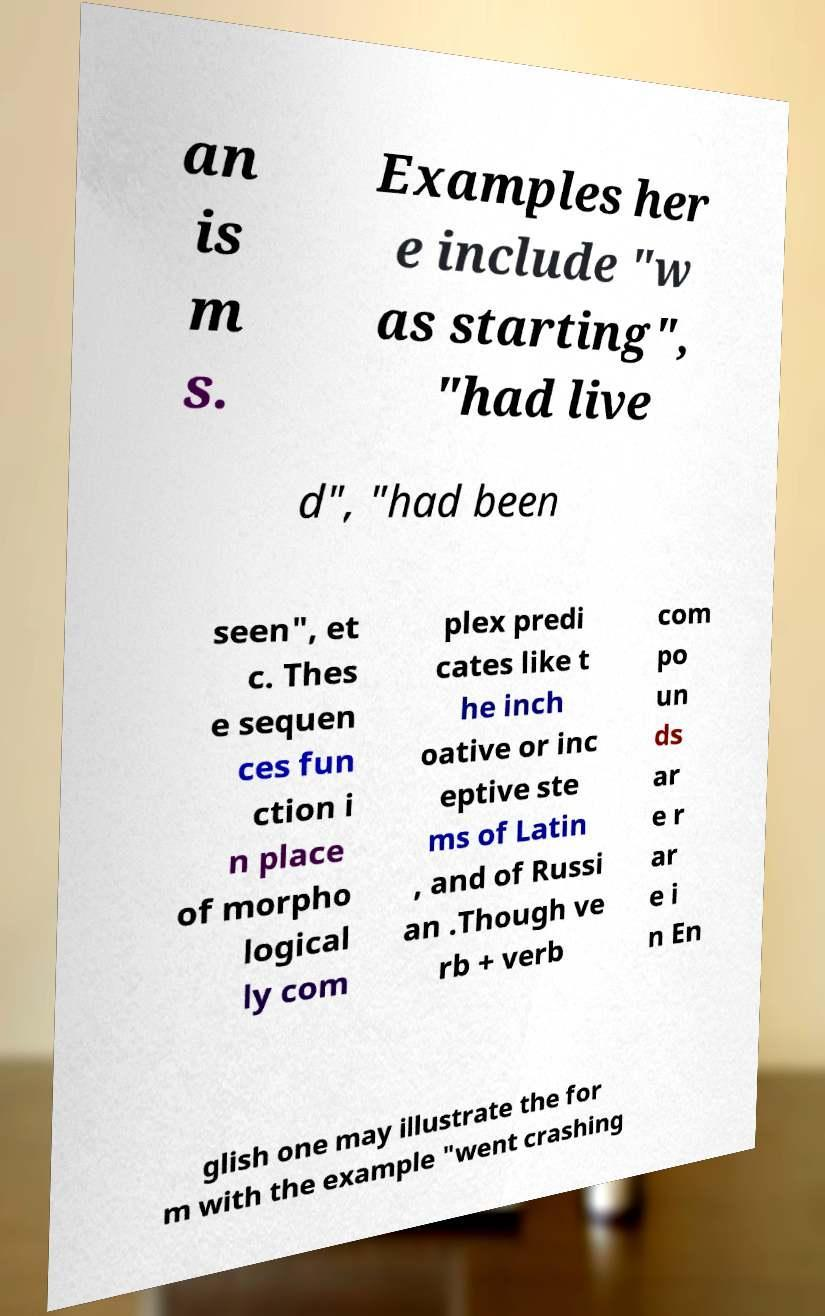Could you assist in decoding the text presented in this image and type it out clearly? an is m s. Examples her e include "w as starting", "had live d", "had been seen", et c. Thes e sequen ces fun ction i n place of morpho logical ly com plex predi cates like t he inch oative or inc eptive ste ms of Latin , and of Russi an .Though ve rb + verb com po un ds ar e r ar e i n En glish one may illustrate the for m with the example "went crashing 